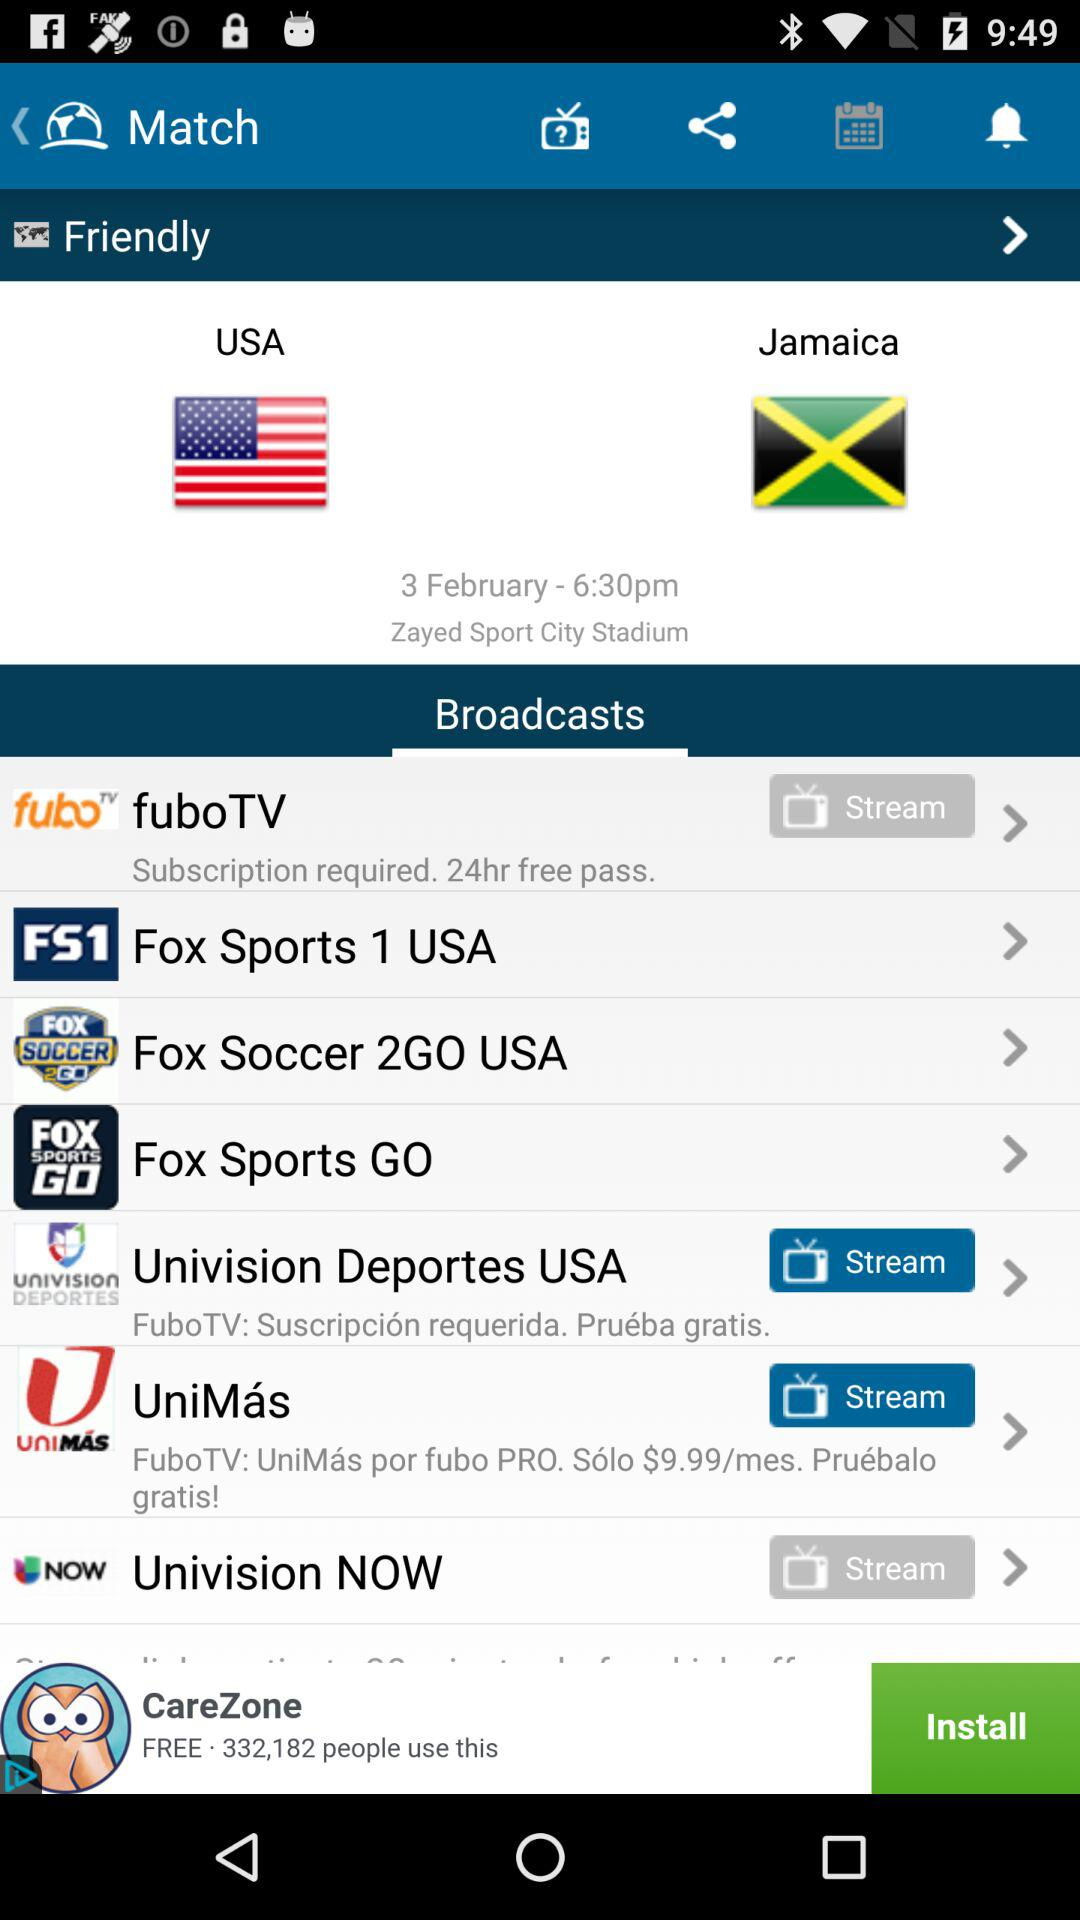What is the date of the match? The date of the match is February 3. 